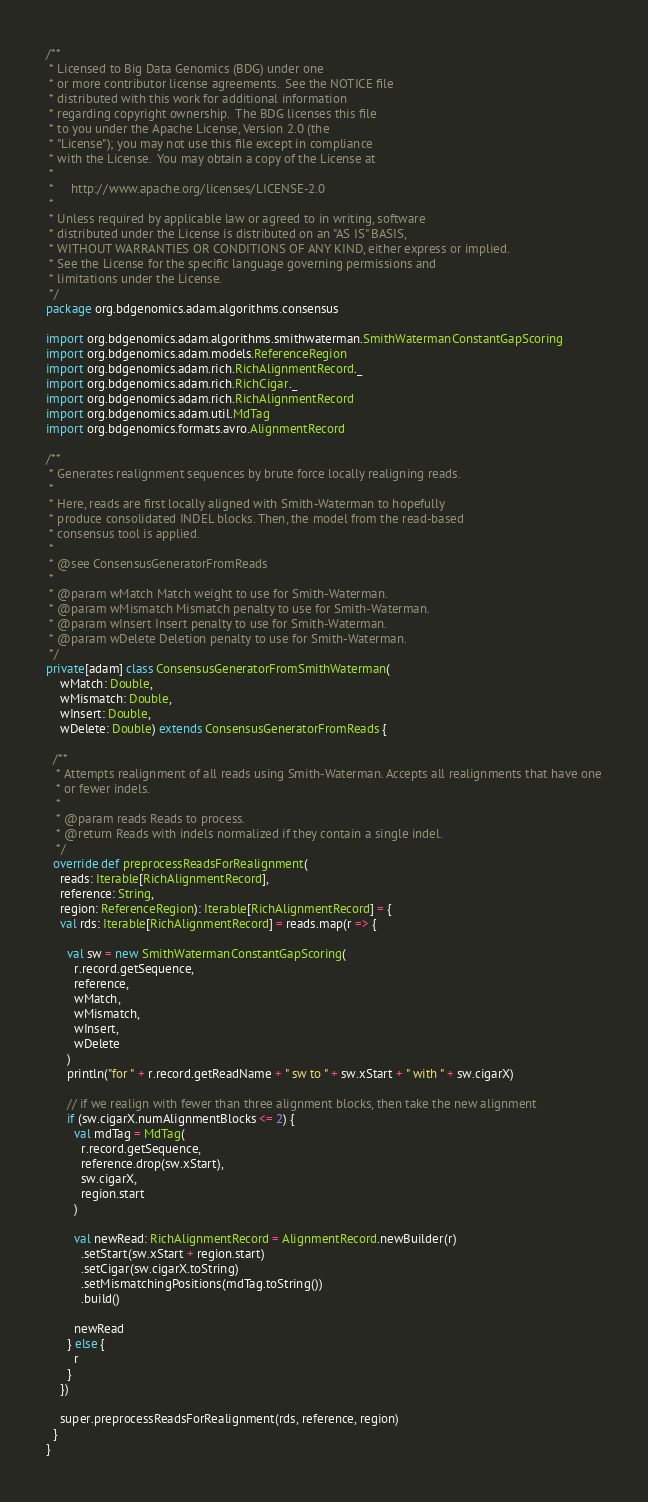<code> <loc_0><loc_0><loc_500><loc_500><_Scala_>/**
 * Licensed to Big Data Genomics (BDG) under one
 * or more contributor license agreements.  See the NOTICE file
 * distributed with this work for additional information
 * regarding copyright ownership.  The BDG licenses this file
 * to you under the Apache License, Version 2.0 (the
 * "License"); you may not use this file except in compliance
 * with the License.  You may obtain a copy of the License at
 *
 *     http://www.apache.org/licenses/LICENSE-2.0
 *
 * Unless required by applicable law or agreed to in writing, software
 * distributed under the License is distributed on an "AS IS" BASIS,
 * WITHOUT WARRANTIES OR CONDITIONS OF ANY KIND, either express or implied.
 * See the License for the specific language governing permissions and
 * limitations under the License.
 */
package org.bdgenomics.adam.algorithms.consensus

import org.bdgenomics.adam.algorithms.smithwaterman.SmithWatermanConstantGapScoring
import org.bdgenomics.adam.models.ReferenceRegion
import org.bdgenomics.adam.rich.RichAlignmentRecord._
import org.bdgenomics.adam.rich.RichCigar._
import org.bdgenomics.adam.rich.RichAlignmentRecord
import org.bdgenomics.adam.util.MdTag
import org.bdgenomics.formats.avro.AlignmentRecord

/**
 * Generates realignment sequences by brute force locally realigning reads.
 *
 * Here, reads are first locally aligned with Smith-Waterman to hopefully
 * produce consolidated INDEL blocks. Then, the model from the read-based
 * consensus tool is applied.
 *
 * @see ConsensusGeneratorFromReads
 *
 * @param wMatch Match weight to use for Smith-Waterman.
 * @param wMismatch Mismatch penalty to use for Smith-Waterman.
 * @param wInsert Insert penalty to use for Smith-Waterman.
 * @param wDelete Deletion penalty to use for Smith-Waterman.
 */
private[adam] class ConsensusGeneratorFromSmithWaterman(
    wMatch: Double,
    wMismatch: Double,
    wInsert: Double,
    wDelete: Double) extends ConsensusGeneratorFromReads {

  /**
   * Attempts realignment of all reads using Smith-Waterman. Accepts all realignments that have one
   * or fewer indels.
   *
   * @param reads Reads to process.
   * @return Reads with indels normalized if they contain a single indel.
   */
  override def preprocessReadsForRealignment(
    reads: Iterable[RichAlignmentRecord],
    reference: String,
    region: ReferenceRegion): Iterable[RichAlignmentRecord] = {
    val rds: Iterable[RichAlignmentRecord] = reads.map(r => {

      val sw = new SmithWatermanConstantGapScoring(
        r.record.getSequence,
        reference,
        wMatch,
        wMismatch,
        wInsert,
        wDelete
      )
      println("for " + r.record.getReadName + " sw to " + sw.xStart + " with " + sw.cigarX)

      // if we realign with fewer than three alignment blocks, then take the new alignment
      if (sw.cigarX.numAlignmentBlocks <= 2) {
        val mdTag = MdTag(
          r.record.getSequence,
          reference.drop(sw.xStart),
          sw.cigarX,
          region.start
        )

        val newRead: RichAlignmentRecord = AlignmentRecord.newBuilder(r)
          .setStart(sw.xStart + region.start)
          .setCigar(sw.cigarX.toString)
          .setMismatchingPositions(mdTag.toString())
          .build()

        newRead
      } else {
        r
      }
    })

    super.preprocessReadsForRealignment(rds, reference, region)
  }
}
</code> 